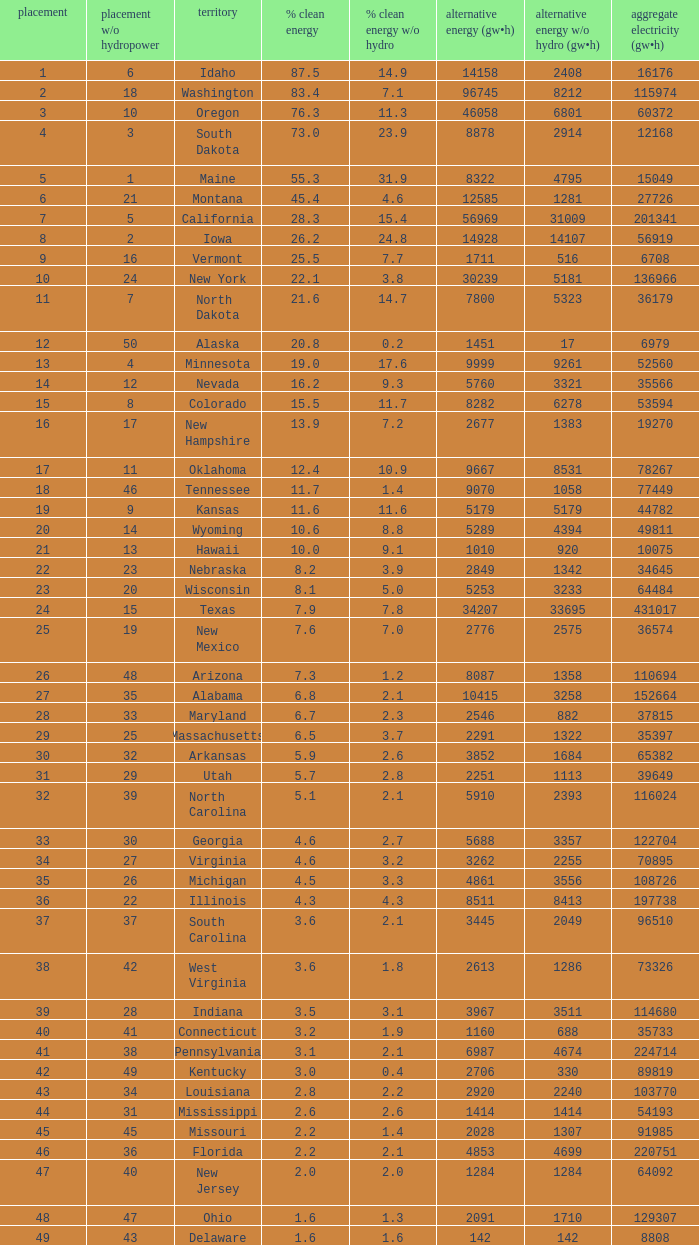Which states have renewable electricity equal to 9667 (gw×h)? Oklahoma. 